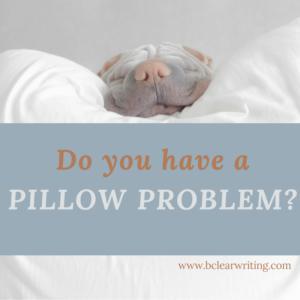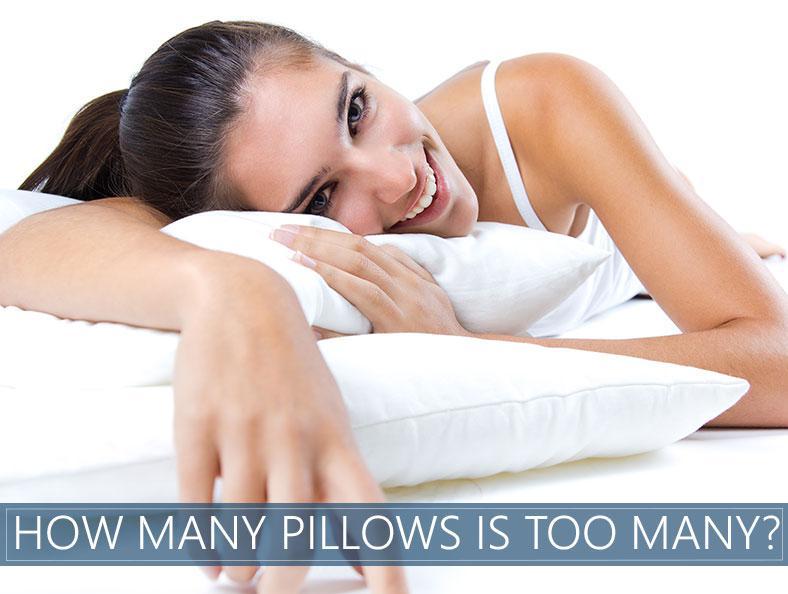The first image is the image on the left, the second image is the image on the right. Given the left and right images, does the statement "White pillows are arranged in front of an upholstered headboard in at least one image." hold true? Answer yes or no. No. 